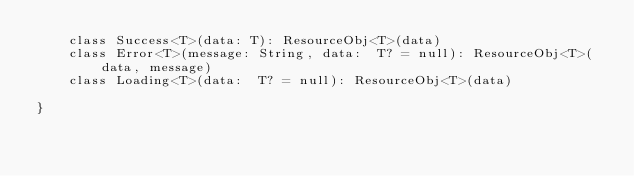Convert code to text. <code><loc_0><loc_0><loc_500><loc_500><_Kotlin_>    class Success<T>(data: T): ResourceObj<T>(data)
    class Error<T>(message: String, data:  T? = null): ResourceObj<T>(data, message)
    class Loading<T>(data:  T? = null): ResourceObj<T>(data)

}
</code> 